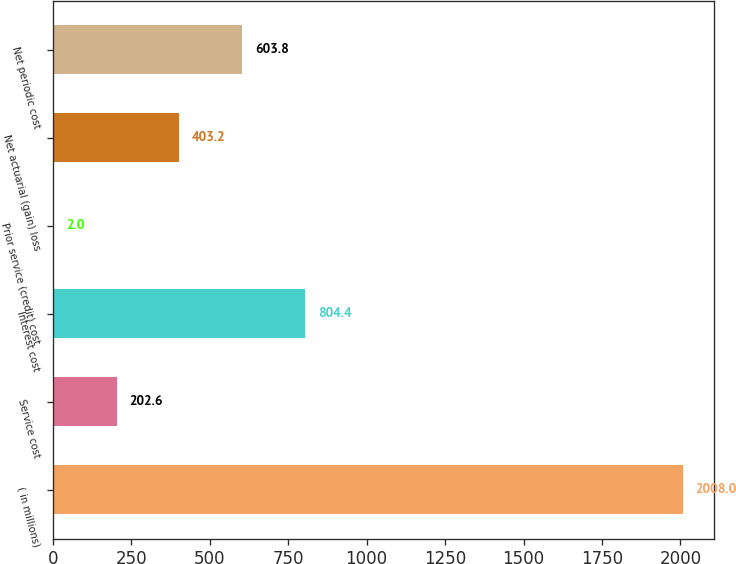<chart> <loc_0><loc_0><loc_500><loc_500><bar_chart><fcel>( in millions)<fcel>Service cost<fcel>Interest cost<fcel>Prior service (credit) cost<fcel>Net actuarial (gain) loss<fcel>Net periodic cost<nl><fcel>2008<fcel>202.6<fcel>804.4<fcel>2<fcel>403.2<fcel>603.8<nl></chart> 